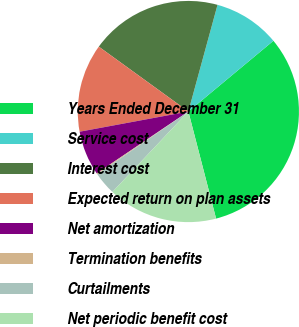Convert chart. <chart><loc_0><loc_0><loc_500><loc_500><pie_chart><fcel>Years Ended December 31<fcel>Service cost<fcel>Interest cost<fcel>Expected return on plan assets<fcel>Net amortization<fcel>Termination benefits<fcel>Curtailments<fcel>Net periodic benefit cost<nl><fcel>32.01%<fcel>9.71%<fcel>19.27%<fcel>12.9%<fcel>6.53%<fcel>0.16%<fcel>3.34%<fcel>16.08%<nl></chart> 